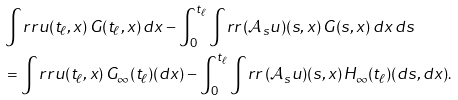<formula> <loc_0><loc_0><loc_500><loc_500>& \int _ { \ } r r u ( t _ { \ell } , x ) \, G ( t _ { \ell } , x ) \, d x - \int _ { 0 } ^ { t _ { \ell } } \int _ { \ } r r \, ( { \mathcal { A } } _ { s } u ) ( s , x ) \, G ( s , x ) \, d x \, d s \\ & = \int _ { \ } r r u ( t _ { \ell } , x ) \, G _ { \infty } ( t _ { \ell } ) ( d x ) - \int _ { 0 } ^ { t _ { \ell } } \int _ { \ } r r \, ( { \mathcal { A } } _ { s } u ) ( s , x ) \, H _ { \infty } ( t _ { \ell } ) ( d s , d x ) .</formula> 